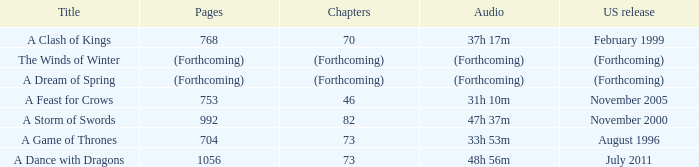How many pages does a dream of spring have? (Forthcoming). 